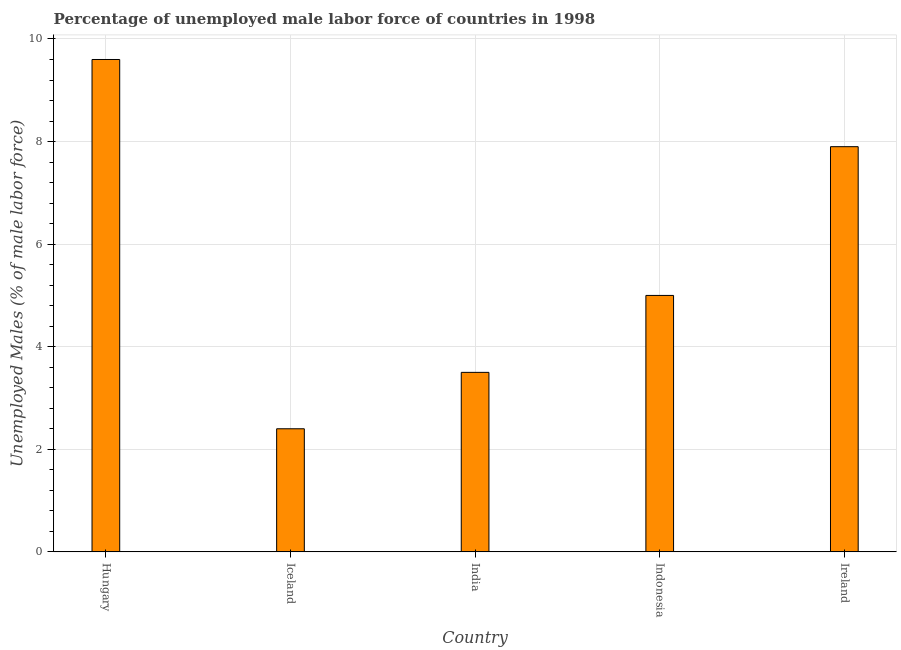Does the graph contain grids?
Ensure brevity in your answer.  Yes. What is the title of the graph?
Provide a short and direct response. Percentage of unemployed male labor force of countries in 1998. What is the label or title of the X-axis?
Ensure brevity in your answer.  Country. What is the label or title of the Y-axis?
Ensure brevity in your answer.  Unemployed Males (% of male labor force). What is the total unemployed male labour force in Hungary?
Ensure brevity in your answer.  9.6. Across all countries, what is the maximum total unemployed male labour force?
Your answer should be very brief. 9.6. Across all countries, what is the minimum total unemployed male labour force?
Offer a very short reply. 2.4. In which country was the total unemployed male labour force maximum?
Provide a succinct answer. Hungary. In which country was the total unemployed male labour force minimum?
Your response must be concise. Iceland. What is the sum of the total unemployed male labour force?
Offer a very short reply. 28.4. What is the average total unemployed male labour force per country?
Offer a terse response. 5.68. What is the median total unemployed male labour force?
Your answer should be very brief. 5. In how many countries, is the total unemployed male labour force greater than 7.6 %?
Your answer should be very brief. 2. What is the ratio of the total unemployed male labour force in Hungary to that in Iceland?
Your answer should be compact. 4. Is the difference between the total unemployed male labour force in Hungary and Ireland greater than the difference between any two countries?
Your response must be concise. No. What is the difference between the highest and the second highest total unemployed male labour force?
Your response must be concise. 1.7. Is the sum of the total unemployed male labour force in Iceland and Indonesia greater than the maximum total unemployed male labour force across all countries?
Ensure brevity in your answer.  No. What is the difference between the highest and the lowest total unemployed male labour force?
Your response must be concise. 7.2. How many bars are there?
Offer a terse response. 5. Are all the bars in the graph horizontal?
Ensure brevity in your answer.  No. How many countries are there in the graph?
Your answer should be very brief. 5. What is the difference between two consecutive major ticks on the Y-axis?
Your answer should be very brief. 2. What is the Unemployed Males (% of male labor force) of Hungary?
Make the answer very short. 9.6. What is the Unemployed Males (% of male labor force) of Iceland?
Provide a succinct answer. 2.4. What is the Unemployed Males (% of male labor force) of India?
Give a very brief answer. 3.5. What is the Unemployed Males (% of male labor force) in Ireland?
Provide a succinct answer. 7.9. What is the difference between the Unemployed Males (% of male labor force) in Hungary and India?
Keep it short and to the point. 6.1. What is the difference between the Unemployed Males (% of male labor force) in Iceland and Indonesia?
Provide a short and direct response. -2.6. What is the difference between the Unemployed Males (% of male labor force) in India and Indonesia?
Offer a very short reply. -1.5. What is the difference between the Unemployed Males (% of male labor force) in India and Ireland?
Provide a succinct answer. -4.4. What is the ratio of the Unemployed Males (% of male labor force) in Hungary to that in India?
Your response must be concise. 2.74. What is the ratio of the Unemployed Males (% of male labor force) in Hungary to that in Indonesia?
Offer a very short reply. 1.92. What is the ratio of the Unemployed Males (% of male labor force) in Hungary to that in Ireland?
Offer a terse response. 1.22. What is the ratio of the Unemployed Males (% of male labor force) in Iceland to that in India?
Provide a short and direct response. 0.69. What is the ratio of the Unemployed Males (% of male labor force) in Iceland to that in Indonesia?
Provide a succinct answer. 0.48. What is the ratio of the Unemployed Males (% of male labor force) in Iceland to that in Ireland?
Your response must be concise. 0.3. What is the ratio of the Unemployed Males (% of male labor force) in India to that in Ireland?
Provide a short and direct response. 0.44. What is the ratio of the Unemployed Males (% of male labor force) in Indonesia to that in Ireland?
Your answer should be compact. 0.63. 